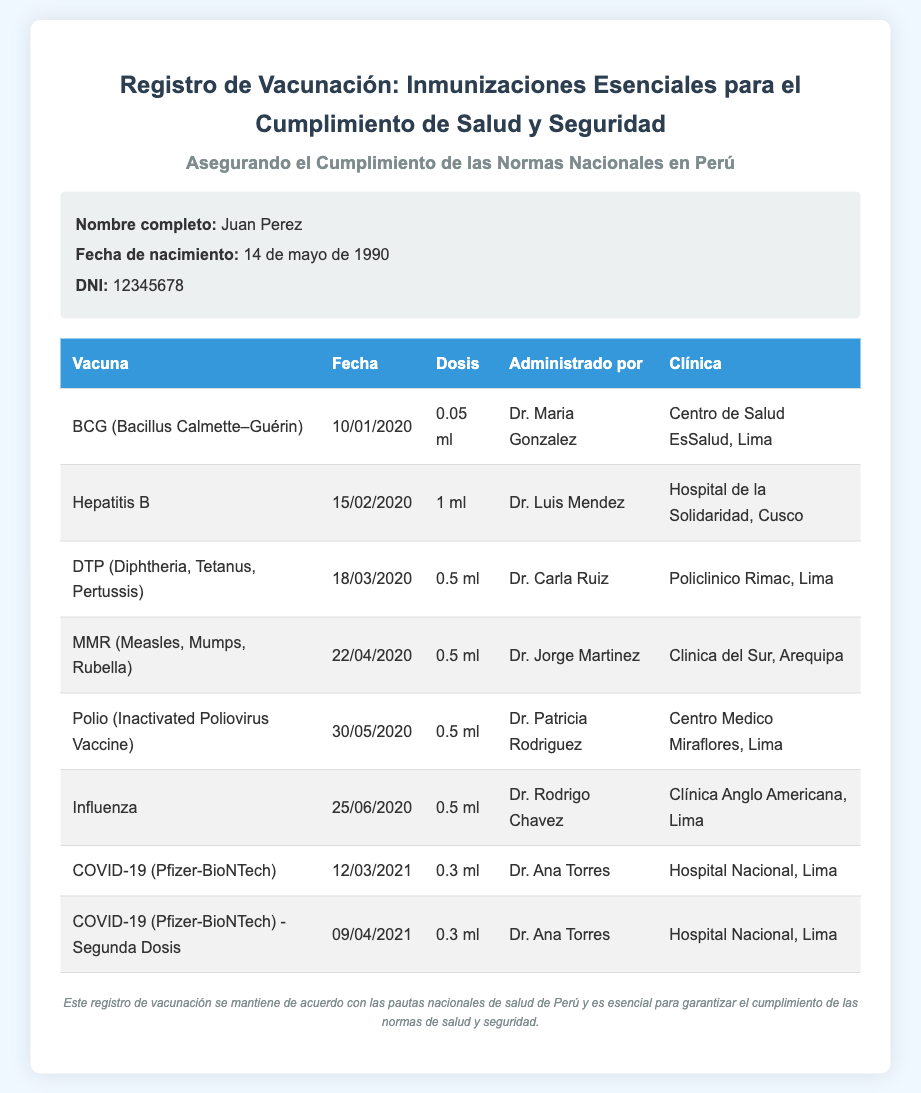¿Cuál es el nombre completo del paciente? El nombre completo del paciente se menciona en la sección de información del paciente.
Answer: Juan Perez ¿Cuál es la fecha de nacimiento del paciente? La fecha de nacimiento está indicada claramente en la sección de información del paciente.
Answer: 14 de mayo de 1990 ¿Quién administró la vacuna de Hepatitis B? La información sobre quién administró cada vacuna se encuentra en la tabla de vacunación.
Answer: Dr. Luis Mendez ¿Cuántas dosis de COVID-19 recibió el paciente? Para encontrar la cantidad de dosis de COVID-19, se debe contar las entradas correspondientes en la tabla de vacunas.
Answer: 2 ¿Cuál es la fecha de la primera dosis de la vacuna de COVID-19? Esta fecha se puede encontrar en la tabla de vacunación donde se detallan las dosis de COVID-19.
Answer: 12/03/2021 ¿Qué vacuna se administró el 25 de junio de 2020? La información sobre las vacunas administradas en fechas específicas está proporcionada en la tabla.
Answer: Influenza ¿Qué clínica administró la vacuna BCG? La clínica donde se administró cada vacuna está listada en la tabla de vacunación.
Answer: Centro de Salud EsSalud, Lima ¿Cuál es el propósito de este registro de vacunación? El propósito se menciona en el descargo de responsabilidad al final del documento.
Answer: Cumplimiento de las normas de salud y seguridad 